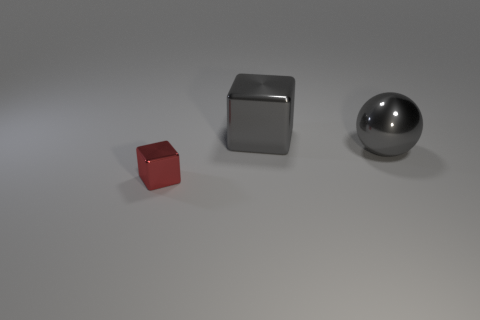Subtract all purple balls. Subtract all gray cylinders. How many balls are left? 1 Add 3 metallic things. How many objects exist? 6 Subtract all spheres. How many objects are left? 2 Add 3 shiny blocks. How many shiny blocks are left? 5 Add 3 big yellow matte objects. How many big yellow matte objects exist? 3 Subtract 0 purple blocks. How many objects are left? 3 Subtract all big purple matte blocks. Subtract all gray blocks. How many objects are left? 2 